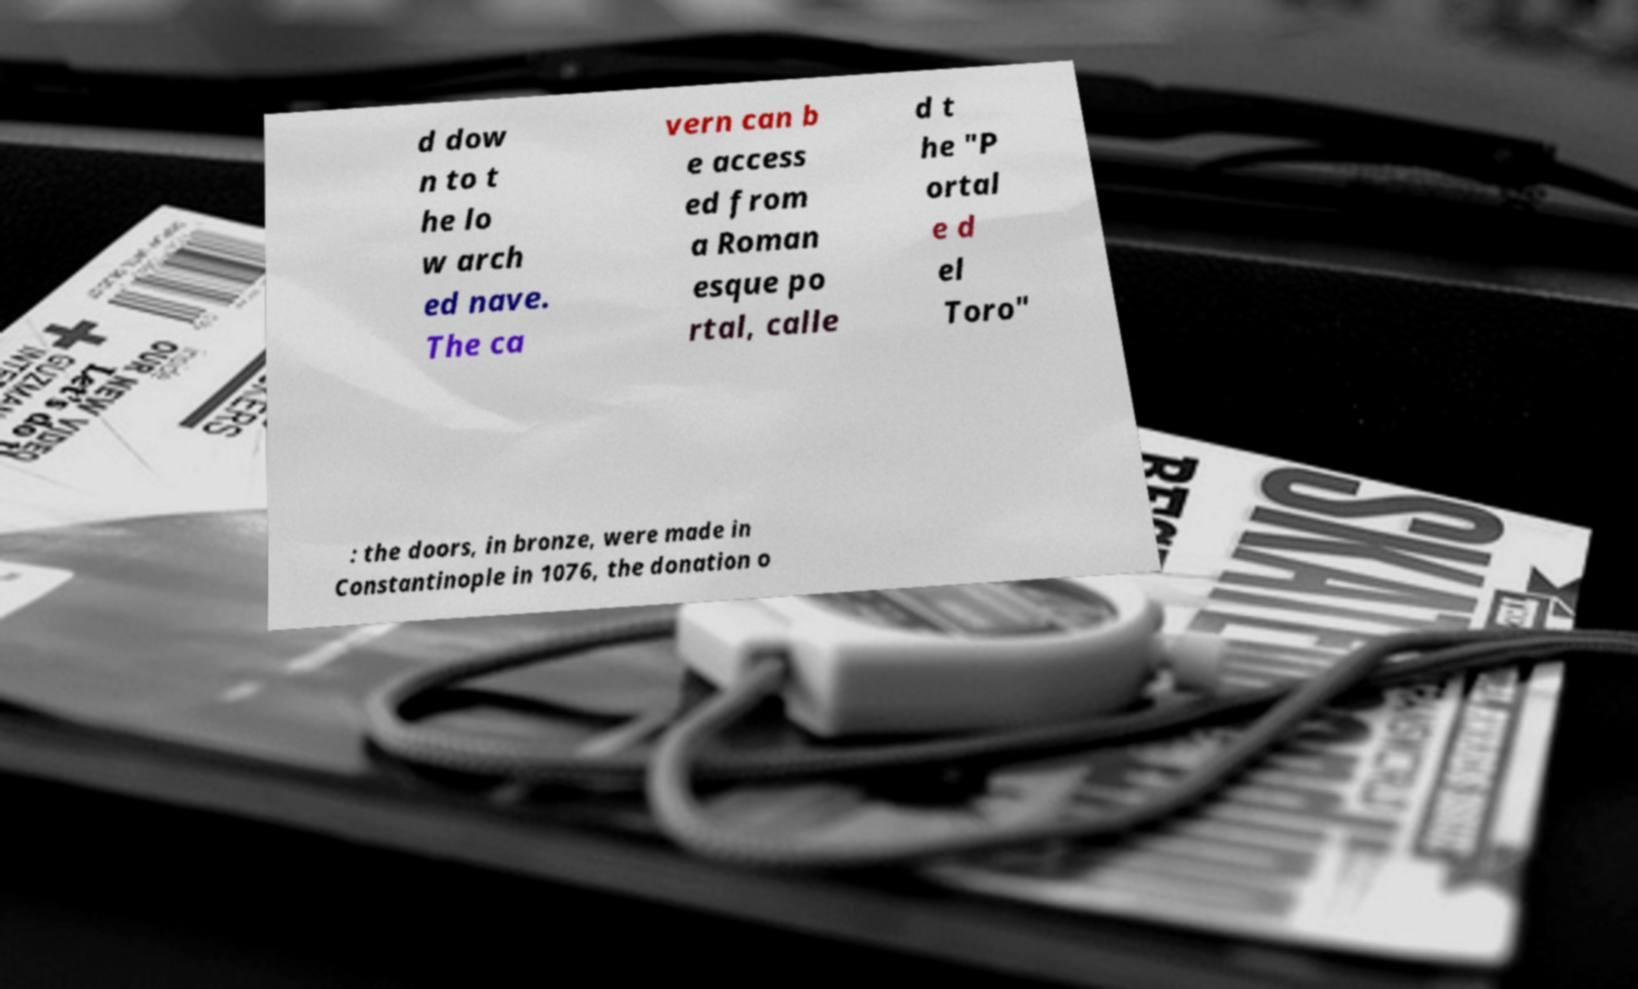Can you read and provide the text displayed in the image?This photo seems to have some interesting text. Can you extract and type it out for me? d dow n to t he lo w arch ed nave. The ca vern can b e access ed from a Roman esque po rtal, calle d t he "P ortal e d el Toro" : the doors, in bronze, were made in Constantinople in 1076, the donation o 